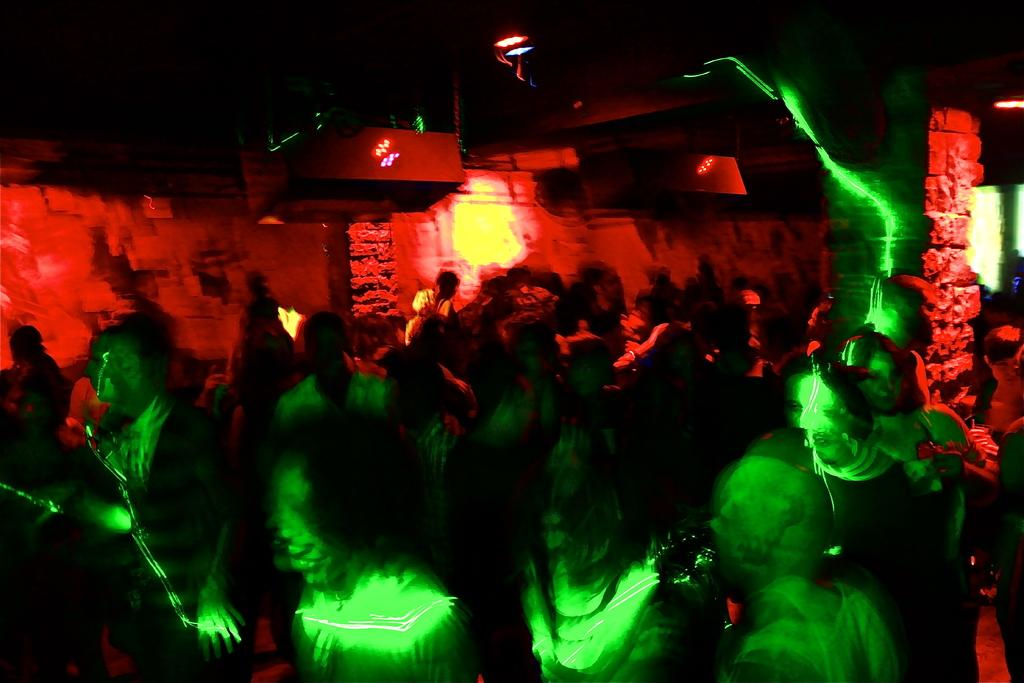How many people are in the image? There are persons in the image, but the exact number is not specified. What type of lighting is present in the image? There are lights in the image, but their specific type or function is not mentioned. What is the background of the image made of? There is a wall in the image, which suggests that the background is made of a solid material. What architectural features can be seen in the image? There are pillars in the image, which are common structural elements. Can you describe any other objects in the image? There are other unspecified objects in the image, but their nature or purpose is not mentioned. What degree of difficulty is the person attempting in the image? There is no indication of any activity or challenge being attempted in the image, so it is not possible to determine a degree of difficulty. 